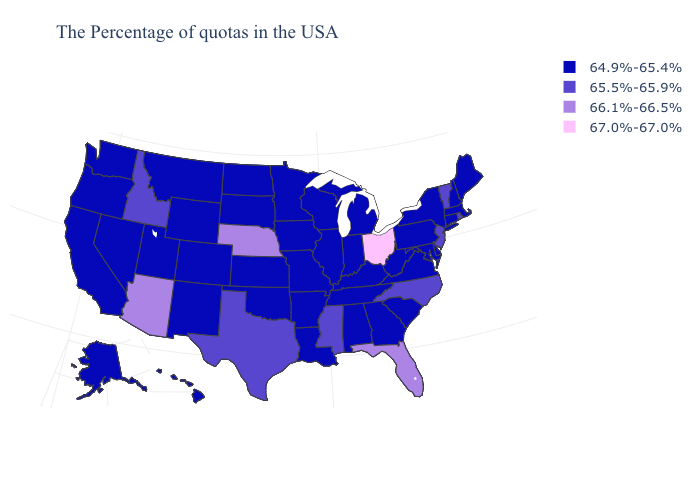Name the states that have a value in the range 65.5%-65.9%?
Answer briefly. Rhode Island, Vermont, New Jersey, North Carolina, Mississippi, Texas, Idaho. Name the states that have a value in the range 66.1%-66.5%?
Write a very short answer. Florida, Nebraska, Arizona. Does Maine have the lowest value in the Northeast?
Give a very brief answer. Yes. Does Kansas have the same value as Nevada?
Keep it brief. Yes. Name the states that have a value in the range 66.1%-66.5%?
Give a very brief answer. Florida, Nebraska, Arizona. What is the value of Missouri?
Keep it brief. 64.9%-65.4%. Name the states that have a value in the range 64.9%-65.4%?
Be succinct. Maine, Massachusetts, New Hampshire, Connecticut, New York, Delaware, Maryland, Pennsylvania, Virginia, South Carolina, West Virginia, Georgia, Michigan, Kentucky, Indiana, Alabama, Tennessee, Wisconsin, Illinois, Louisiana, Missouri, Arkansas, Minnesota, Iowa, Kansas, Oklahoma, South Dakota, North Dakota, Wyoming, Colorado, New Mexico, Utah, Montana, Nevada, California, Washington, Oregon, Alaska, Hawaii. Does Vermont have the same value as Arizona?
Quick response, please. No. Name the states that have a value in the range 65.5%-65.9%?
Answer briefly. Rhode Island, Vermont, New Jersey, North Carolina, Mississippi, Texas, Idaho. Does Iowa have the lowest value in the USA?
Be succinct. Yes. What is the lowest value in the USA?
Write a very short answer. 64.9%-65.4%. Among the states that border Tennessee , does North Carolina have the lowest value?
Concise answer only. No. Among the states that border Connecticut , does Rhode Island have the highest value?
Answer briefly. Yes. What is the value of Montana?
Be succinct. 64.9%-65.4%. What is the value of New Jersey?
Give a very brief answer. 65.5%-65.9%. 